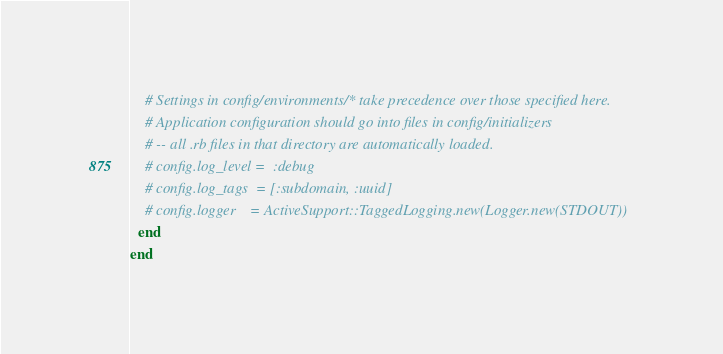Convert code to text. <code><loc_0><loc_0><loc_500><loc_500><_Ruby_>    # Settings in config/environments/* take precedence over those specified here.
    # Application configuration should go into files in config/initializers
    # -- all .rb files in that directory are automatically loaded.
    # config.log_level =  :debug
    # config.log_tags  = [:subdomain, :uuid]
    # config.logger    = ActiveSupport::TaggedLogging.new(Logger.new(STDOUT))
  end
end
</code> 